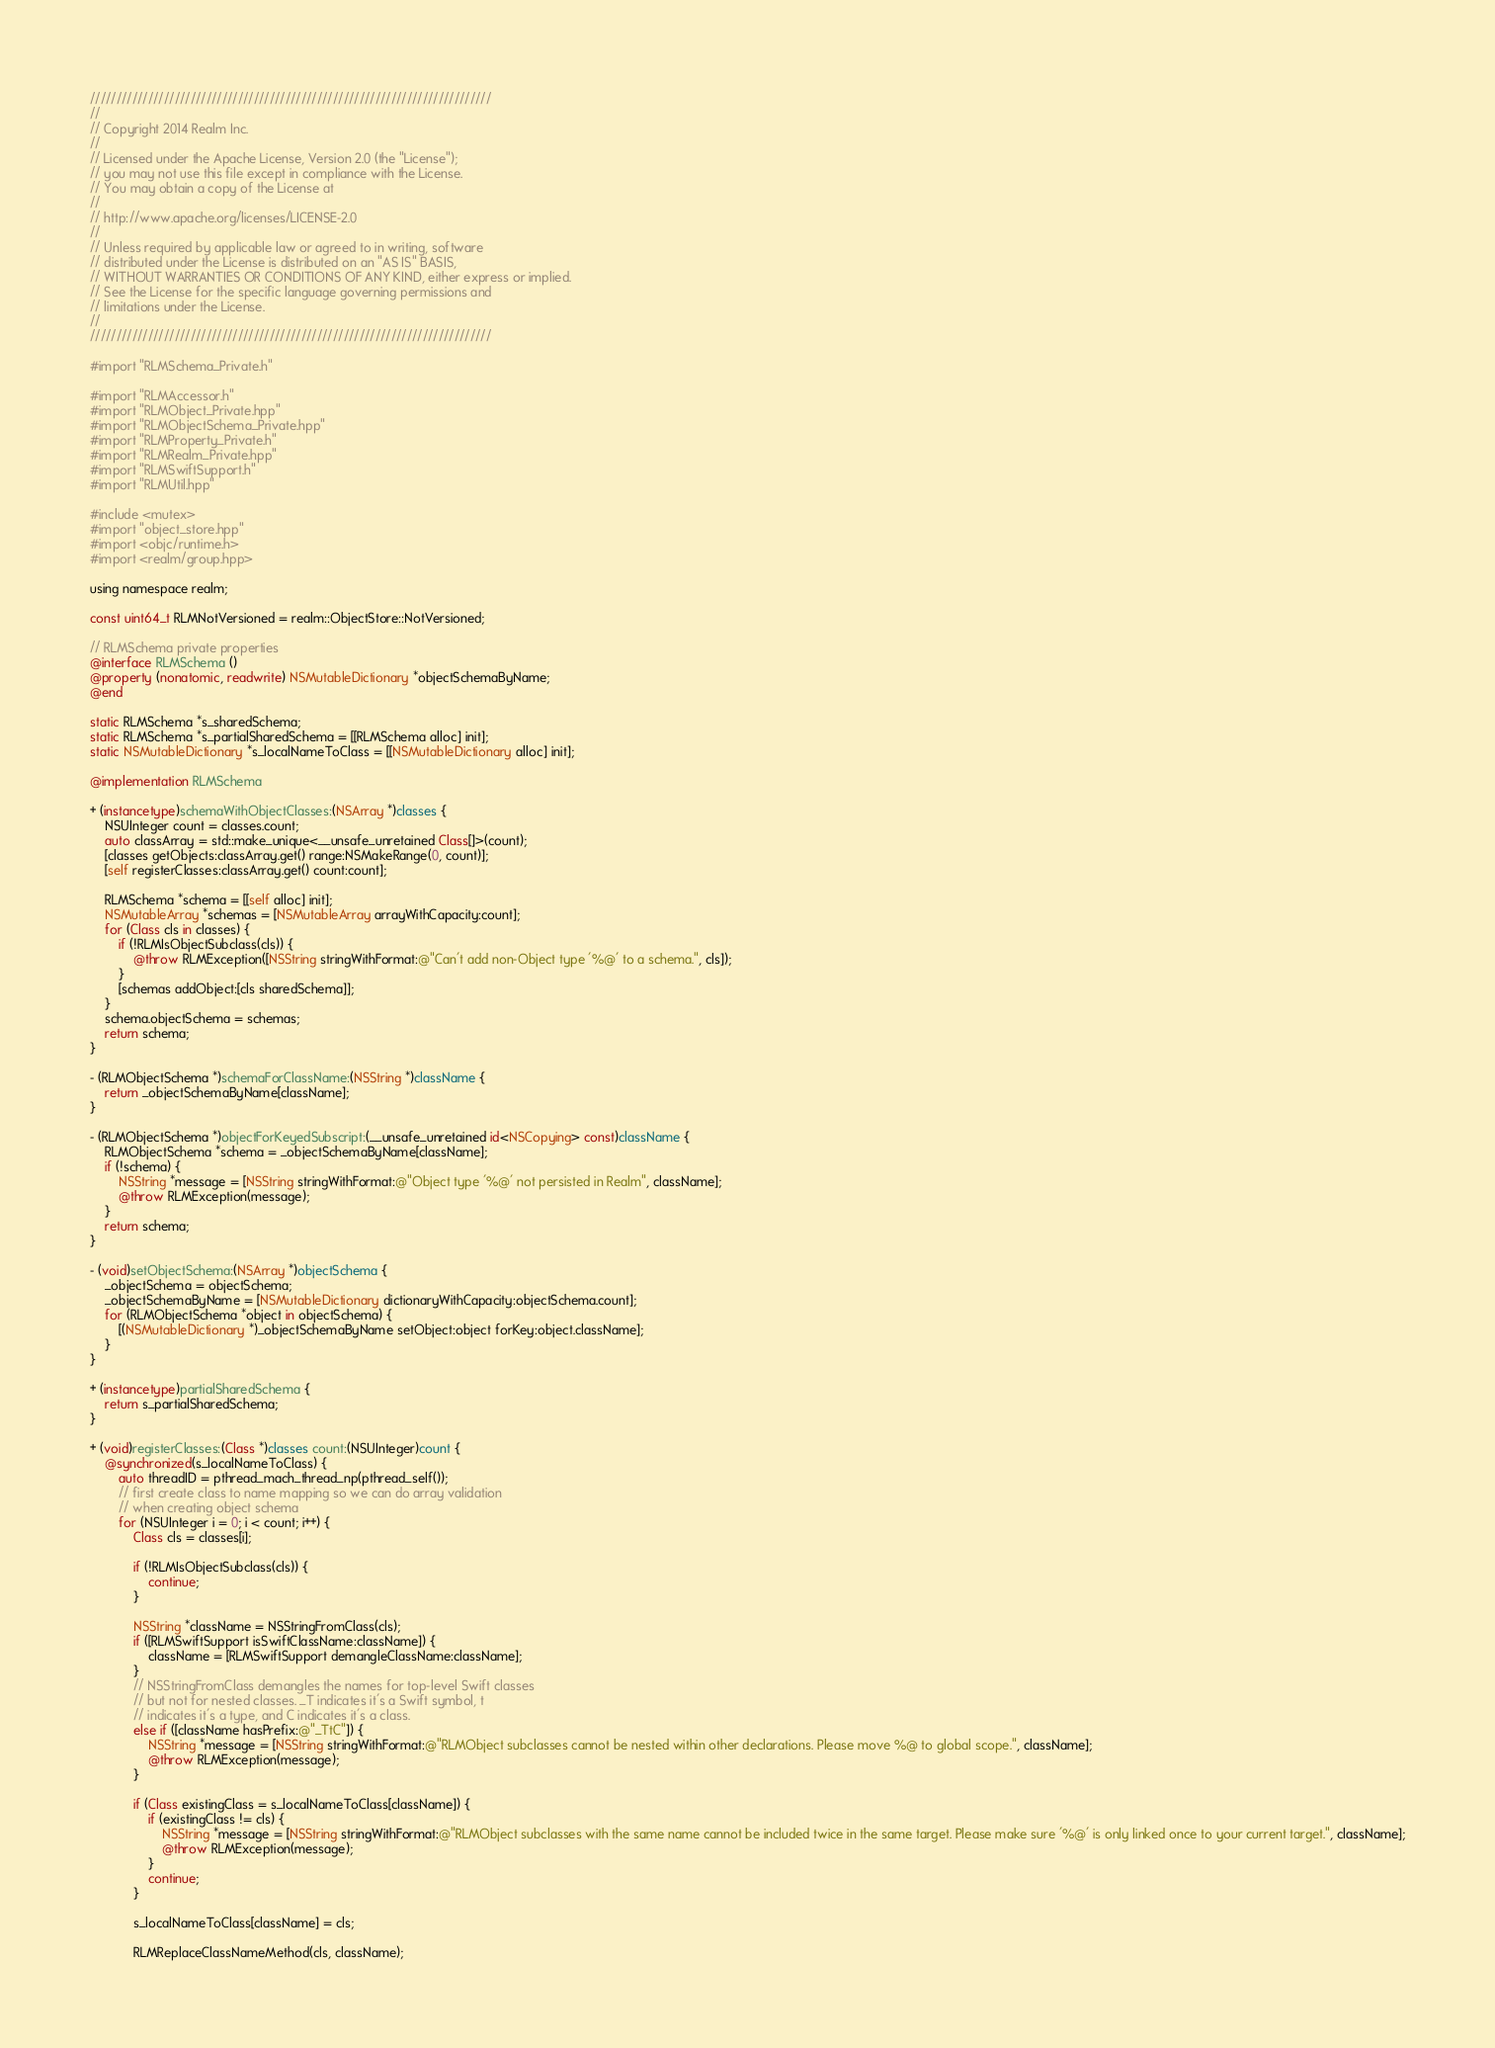Convert code to text. <code><loc_0><loc_0><loc_500><loc_500><_ObjectiveC_>////////////////////////////////////////////////////////////////////////////
//
// Copyright 2014 Realm Inc.
//
// Licensed under the Apache License, Version 2.0 (the "License");
// you may not use this file except in compliance with the License.
// You may obtain a copy of the License at
//
// http://www.apache.org/licenses/LICENSE-2.0
//
// Unless required by applicable law or agreed to in writing, software
// distributed under the License is distributed on an "AS IS" BASIS,
// WITHOUT WARRANTIES OR CONDITIONS OF ANY KIND, either express or implied.
// See the License for the specific language governing permissions and
// limitations under the License.
//
////////////////////////////////////////////////////////////////////////////

#import "RLMSchema_Private.h"

#import "RLMAccessor.h"
#import "RLMObject_Private.hpp"
#import "RLMObjectSchema_Private.hpp"
#import "RLMProperty_Private.h"
#import "RLMRealm_Private.hpp"
#import "RLMSwiftSupport.h"
#import "RLMUtil.hpp"

#include <mutex>
#import "object_store.hpp"
#import <objc/runtime.h>
#import <realm/group.hpp>

using namespace realm;

const uint64_t RLMNotVersioned = realm::ObjectStore::NotVersioned;

// RLMSchema private properties
@interface RLMSchema ()
@property (nonatomic, readwrite) NSMutableDictionary *objectSchemaByName;
@end

static RLMSchema *s_sharedSchema;
static RLMSchema *s_partialSharedSchema = [[RLMSchema alloc] init];
static NSMutableDictionary *s_localNameToClass = [[NSMutableDictionary alloc] init];

@implementation RLMSchema

+ (instancetype)schemaWithObjectClasses:(NSArray *)classes {
    NSUInteger count = classes.count;
    auto classArray = std::make_unique<__unsafe_unretained Class[]>(count);
    [classes getObjects:classArray.get() range:NSMakeRange(0, count)];
    [self registerClasses:classArray.get() count:count];

    RLMSchema *schema = [[self alloc] init];
    NSMutableArray *schemas = [NSMutableArray arrayWithCapacity:count];
    for (Class cls in classes) {
        if (!RLMIsObjectSubclass(cls)) {
            @throw RLMException([NSString stringWithFormat:@"Can't add non-Object type '%@' to a schema.", cls]);
        }
        [schemas addObject:[cls sharedSchema]];
    }
    schema.objectSchema = schemas;
    return schema;
}

- (RLMObjectSchema *)schemaForClassName:(NSString *)className {
    return _objectSchemaByName[className];
}

- (RLMObjectSchema *)objectForKeyedSubscript:(__unsafe_unretained id<NSCopying> const)className {
    RLMObjectSchema *schema = _objectSchemaByName[className];
    if (!schema) {
        NSString *message = [NSString stringWithFormat:@"Object type '%@' not persisted in Realm", className];
        @throw RLMException(message);
    }
    return schema;
}

- (void)setObjectSchema:(NSArray *)objectSchema {
    _objectSchema = objectSchema;
    _objectSchemaByName = [NSMutableDictionary dictionaryWithCapacity:objectSchema.count];
    for (RLMObjectSchema *object in objectSchema) {
        [(NSMutableDictionary *)_objectSchemaByName setObject:object forKey:object.className];
    }
}

+ (instancetype)partialSharedSchema {
    return s_partialSharedSchema;
}

+ (void)registerClasses:(Class *)classes count:(NSUInteger)count {
    @synchronized(s_localNameToClass) {
        auto threadID = pthread_mach_thread_np(pthread_self());
        // first create class to name mapping so we can do array validation
        // when creating object schema
        for (NSUInteger i = 0; i < count; i++) {
            Class cls = classes[i];

            if (!RLMIsObjectSubclass(cls)) {
                continue;
            }

            NSString *className = NSStringFromClass(cls);
            if ([RLMSwiftSupport isSwiftClassName:className]) {
                className = [RLMSwiftSupport demangleClassName:className];
            }
            // NSStringFromClass demangles the names for top-level Swift classes
            // but not for nested classes. _T indicates it's a Swift symbol, t
            // indicates it's a type, and C indicates it's a class.
            else if ([className hasPrefix:@"_TtC"]) {
                NSString *message = [NSString stringWithFormat:@"RLMObject subclasses cannot be nested within other declarations. Please move %@ to global scope.", className];
                @throw RLMException(message);
            }

            if (Class existingClass = s_localNameToClass[className]) {
                if (existingClass != cls) {
                    NSString *message = [NSString stringWithFormat:@"RLMObject subclasses with the same name cannot be included twice in the same target. Please make sure '%@' is only linked once to your current target.", className];
                    @throw RLMException(message);
                }
                continue;
            }

            s_localNameToClass[className] = cls;

            RLMReplaceClassNameMethod(cls, className);</code> 